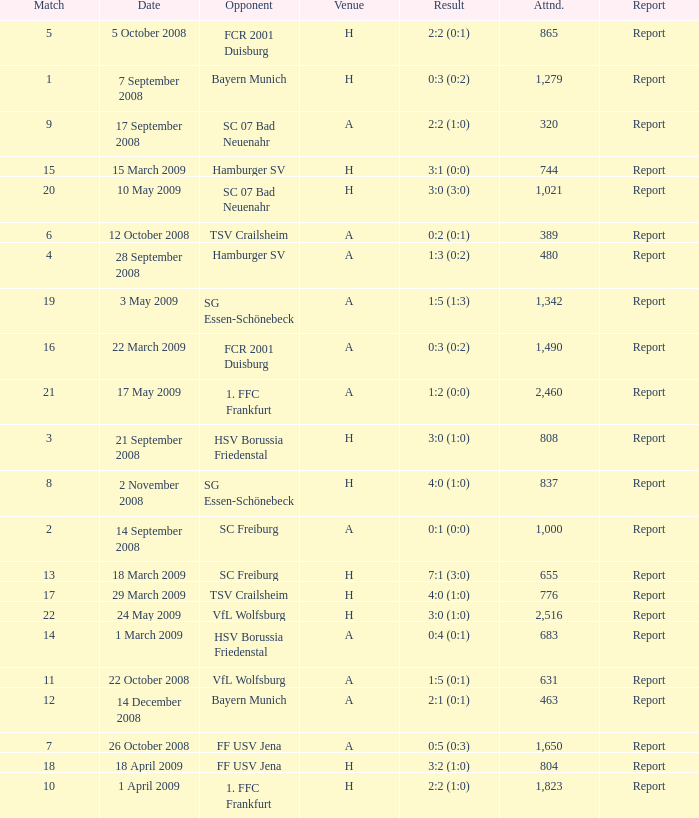What is the match number that had a result of 0:5 (0:3)? 1.0. 